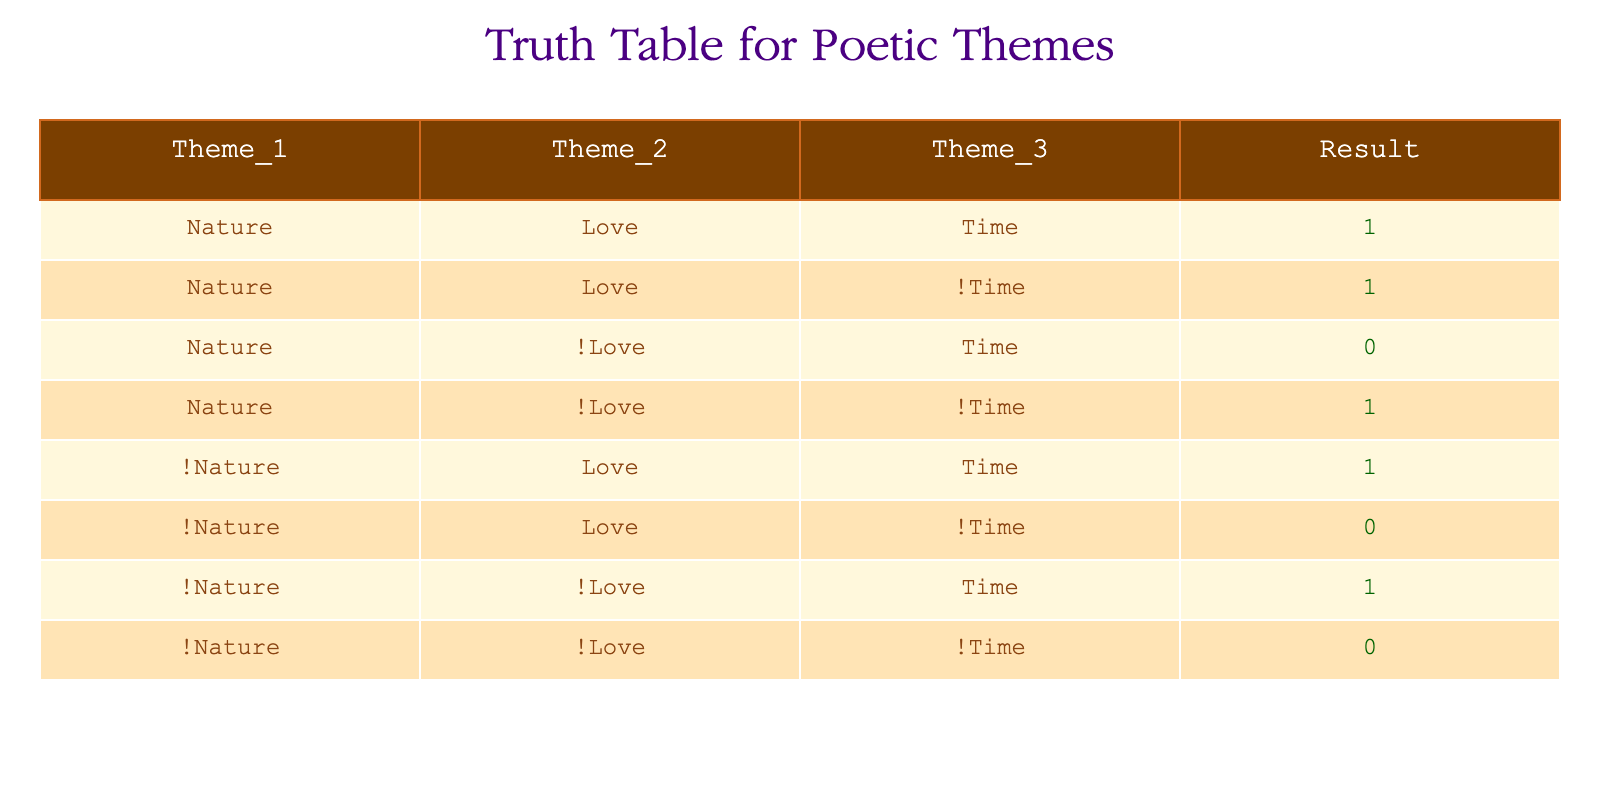What is the result when Nature and Love are both present and Time is also present? In the table, looking at the row where Theme_1 is Nature, Theme_2 is Love, and Theme_3 is Time, the Result is 1.
Answer: 1 What is the result when Nature is present and Love is absent while Time is absent? Referring to the row where Theme_1 is Nature, Theme_2 is !Love, and Theme_3 is !Time, the Result is 1.
Answer: 1 Is the result 1 when Nature is absent and Love is present, regardless of Time? There are two rows where !Nature and Love are present, one with Time (which gives a Result of 1) and one without Time (which gives a Result of 0). Thus, the assertion is false.
Answer: No What is the total number of instances where Nature is involved, regardless of Love and Time? Analyzing the rows with Nature (including both with and without Love and Time), there are four rows contributing to the Result. Out of these, two have a Result of 1. Thus, counting them gives 4 instances.
Answer: 4 Is there a case where Nature is present, Love is absent, and Time is present? Looking at the table, there is no row that matches this criteria (Nature present, !Love present, Time present), since the Result is 0 for that combination.
Answer: No What is the relationship between Love and the Result when Nature is absent and Time is present? Examining the rows with !Nature and Love present while Time is present both yield a Result of 1. Thus, Love positively influences the Result in this context.
Answer: Yes How many combinations yield a result of 0? By reviewing the table, there are three combinations resulting in 0: (!Nature, !Love, Time), (!Nature, Love, !Time), and (Nature, !Love, Time). Therefore, there are three such combinations.
Answer: 3 What is the conclusion about the relationship between the themes based on the table's results? The table reveals that the combinations of themes significantly influence the Result. Specifically, combinations that include both Nature and Love yield a high Result, particularly when Time is involved, whereas the absence of either Nature or Love often leads to a Result of 0.
Answer: Nature and Love contribute positively to the Result 